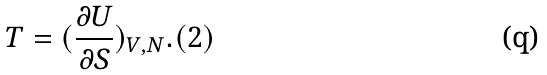<formula> <loc_0><loc_0><loc_500><loc_500>T = ( \frac { \partial U } { \partial S } ) _ { V , N } . ( 2 )</formula> 